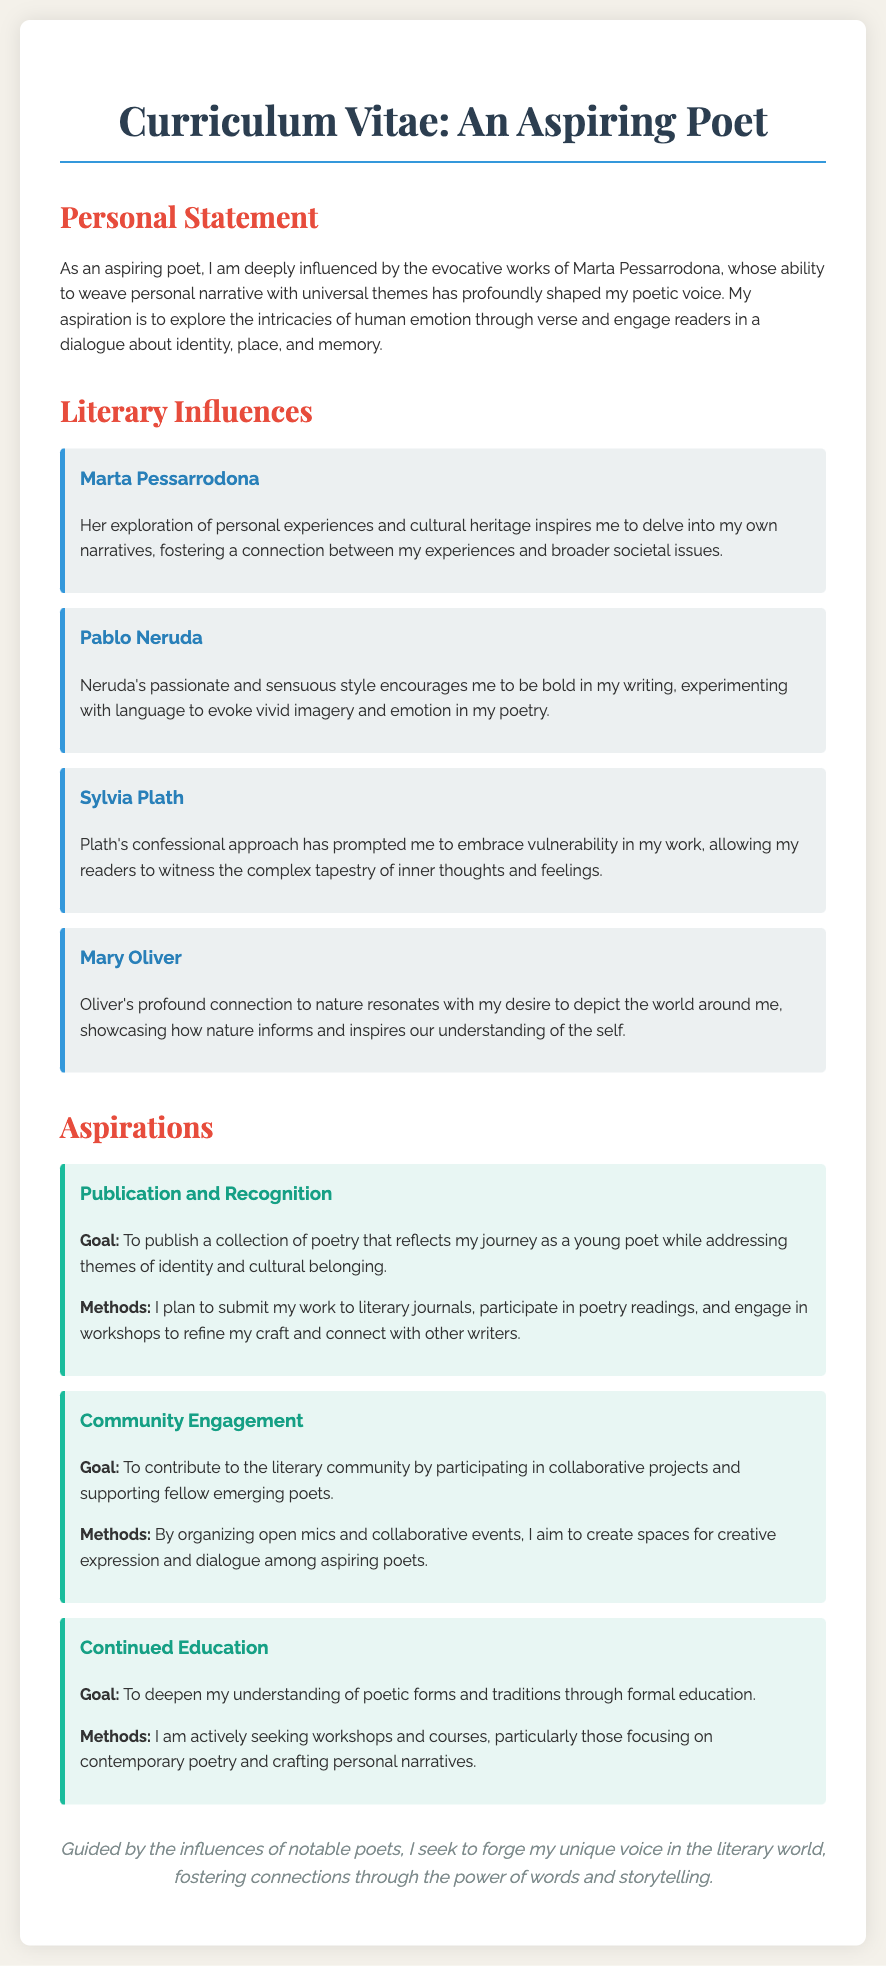What is the title of the document? The title of the document, as stated in the heading, is "Aspiring Poet's Curriculum Vitae."
Answer: Aspiring Poet's Curriculum Vitae Who is the main literary influence mentioned? The main literary influence highlighted in the document is Marta Pessarrodona.
Answer: Marta Pessarrodona What is one goal related to community engagement mentioned? One goal mentioned in the community engagement section is to contribute to the literary community.
Answer: Contribute to the literary community Which poet's style encourages boldness in writing? The poet whose style encourages boldness in writing is Pablo Neruda.
Answer: Pablo Neruda What is one method for achieving publication and recognition? One method for achieving publication and recognition is participating in poetry readings.
Answer: Participating in poetry readings What does the conclusion suggest about the aspiring poet's journey? The conclusion suggests that the aspiring poet seeks to forge a unique voice in the literary world.
Answer: Forge a unique voice in the literary world What type of educational opportunities is the aspiring poet seeking? The aspiring poet is seeking workshops and courses.
Answer: Workshops and courses Which poet's confessional approach is mentioned? The poet with a confessional approach mentioned is Sylvia Plath.
Answer: Sylvia Plath What theme does the aspiring poet intend to address in their poetry? The theme the aspiring poet intends to address is identity and cultural belonging.
Answer: Identity and cultural belonging 